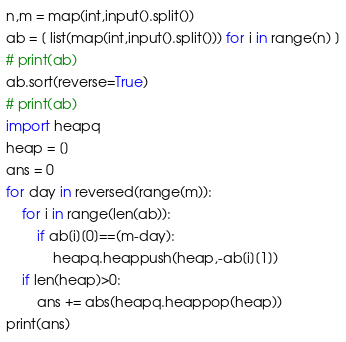Convert code to text. <code><loc_0><loc_0><loc_500><loc_500><_Python_>n,m = map(int,input().split())
ab = [ list(map(int,input().split())) for i in range(n) ]
# print(ab)
ab.sort(reverse=True)
# print(ab)
import heapq
heap = []
ans = 0
for day in reversed(range(m)):
    for i in range(len(ab)):
        if ab[i][0]==(m-day):
            heapq.heappush(heap,-ab[i][1])
    if len(heap)>0:
        ans += abs(heapq.heappop(heap))
print(ans)</code> 